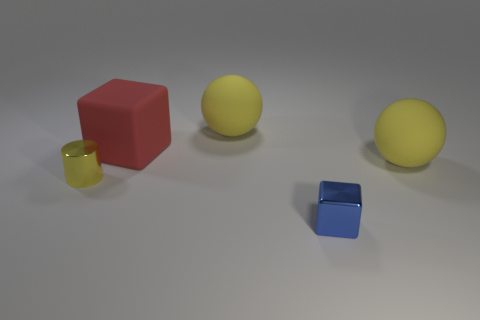What number of things are large yellow rubber things or yellow spheres right of the small metal cube? 2 